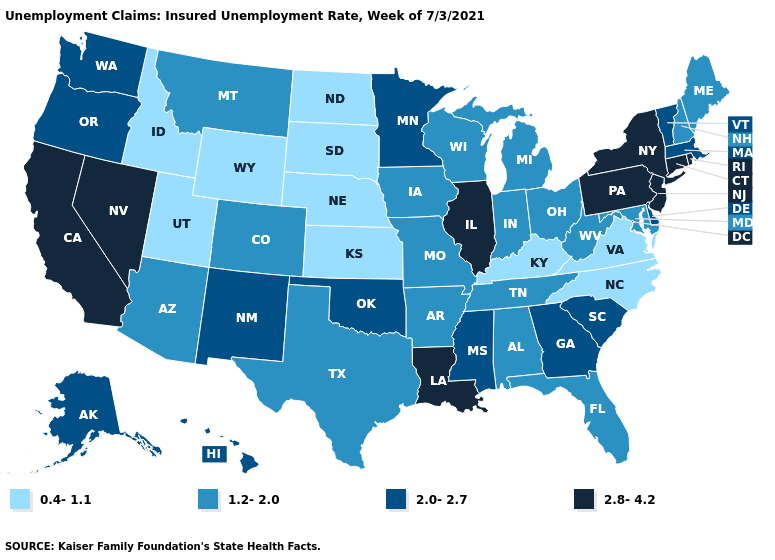Does the first symbol in the legend represent the smallest category?
Short answer required. Yes. What is the value of Oregon?
Short answer required. 2.0-2.7. Does the map have missing data?
Be succinct. No. What is the value of Texas?
Short answer required. 1.2-2.0. What is the value of Illinois?
Short answer required. 2.8-4.2. Which states have the highest value in the USA?
Concise answer only. California, Connecticut, Illinois, Louisiana, Nevada, New Jersey, New York, Pennsylvania, Rhode Island. Name the states that have a value in the range 1.2-2.0?
Quick response, please. Alabama, Arizona, Arkansas, Colorado, Florida, Indiana, Iowa, Maine, Maryland, Michigan, Missouri, Montana, New Hampshire, Ohio, Tennessee, Texas, West Virginia, Wisconsin. Which states have the highest value in the USA?
Be succinct. California, Connecticut, Illinois, Louisiana, Nevada, New Jersey, New York, Pennsylvania, Rhode Island. Which states have the lowest value in the MidWest?
Keep it brief. Kansas, Nebraska, North Dakota, South Dakota. Which states have the highest value in the USA?
Concise answer only. California, Connecticut, Illinois, Louisiana, Nevada, New Jersey, New York, Pennsylvania, Rhode Island. What is the value of Delaware?
Write a very short answer. 2.0-2.7. What is the value of Florida?
Short answer required. 1.2-2.0. Does Wyoming have the lowest value in the West?
Keep it brief. Yes. What is the value of Rhode Island?
Keep it brief. 2.8-4.2. Name the states that have a value in the range 1.2-2.0?
Give a very brief answer. Alabama, Arizona, Arkansas, Colorado, Florida, Indiana, Iowa, Maine, Maryland, Michigan, Missouri, Montana, New Hampshire, Ohio, Tennessee, Texas, West Virginia, Wisconsin. 